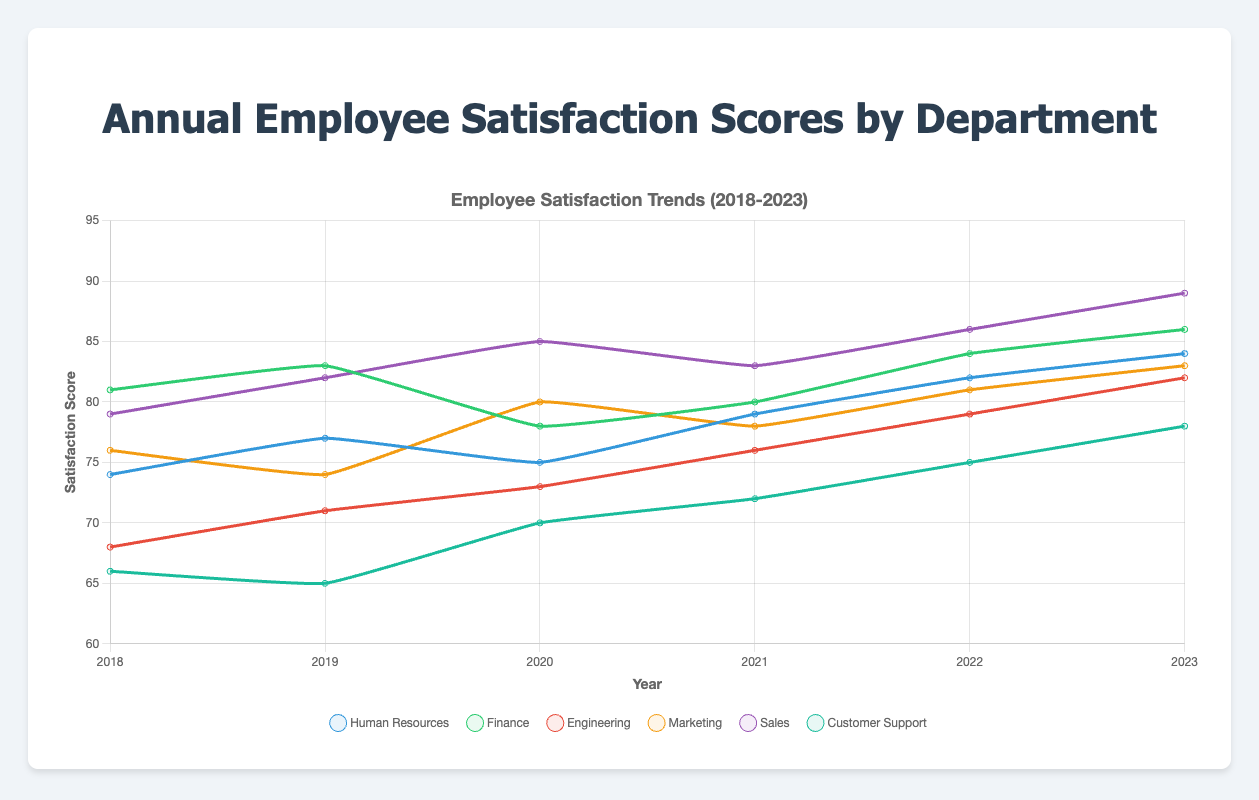What was the trend of the satisfaction score for the Marketing department from 2018 to 2023? The scores for Marketing were 76, 74, 80, 78, 81, and 83 respectively from 2018 to 2023. This shows an overall increasing trend from 76 to 83. Although there was a slight decline between 2018 and 2019, the score then increased steadily again.
Answer: Increasing trend Which department had the highest satisfaction score in 2020, and what was the score? From the data, Finance had the highest satisfaction score in 2020 with a score of 78.
Answer: Finance with a score of 78 Compare the satisfaction score trends between the Engineering and Customer Support departments from 2018 to 2023. The scores for Engineering from 2018-2023 are 68, 71, 73, 76, 79, and 82, showing a steady increase each year. For Customer Support, the scores are 66, 65, 70, 72, 75, and 78, which shows an overall increase as well, but with fluctuations, particularly a drop from 2018 to 2019. Overall, Engineering had a more consistent upward trend compared to Customer Support.
Answer: Engineering had a steadier increase What is the average satisfaction score for the Sales department over the period 2018 to 2023? The scores for Sales from 2018-2023 are 79, 82, 85, 83, 86, and 89. Adding these values gives 504, and dividing by the number of years (6) gives an average score of 84.
Answer: 84 Which department saw the greatest improvement in satisfaction scores from 2018 to 2023? Comparing the scores between 2018 and 2023, Engineering improved from 68 to 82, which is an increase of 14 points. Other departments had smaller increases. Thus, Engineering saw the greatest improvement.
Answer: Engineering How did the satisfaction scores for the Finance department change from 2018 to 2023? The scores for Finance were 81, 83, 78, 80, 84, and 86 from 2018 to 2023, respectively. There was a slight decline between 2019 and 2020, but the overall trend is an increase from 81 to 86.
Answer: Increased from 81 to 86 In which year did Customer Support have the largest satisfaction score, and what was it? Customer Support had the highest satisfaction score in 2023 with a score of 78.
Answer: 2023 with a score of 78 What was the percentage change in satisfaction scores for Human Resources from 2018 to 2023? Human Resources' scores were 74 in 2018 and 84 in 2023. The percentage change can be calculated as ((84 - 74) / 74) * 100%, which results in approximately 13.51%.
Answer: 13.51% 